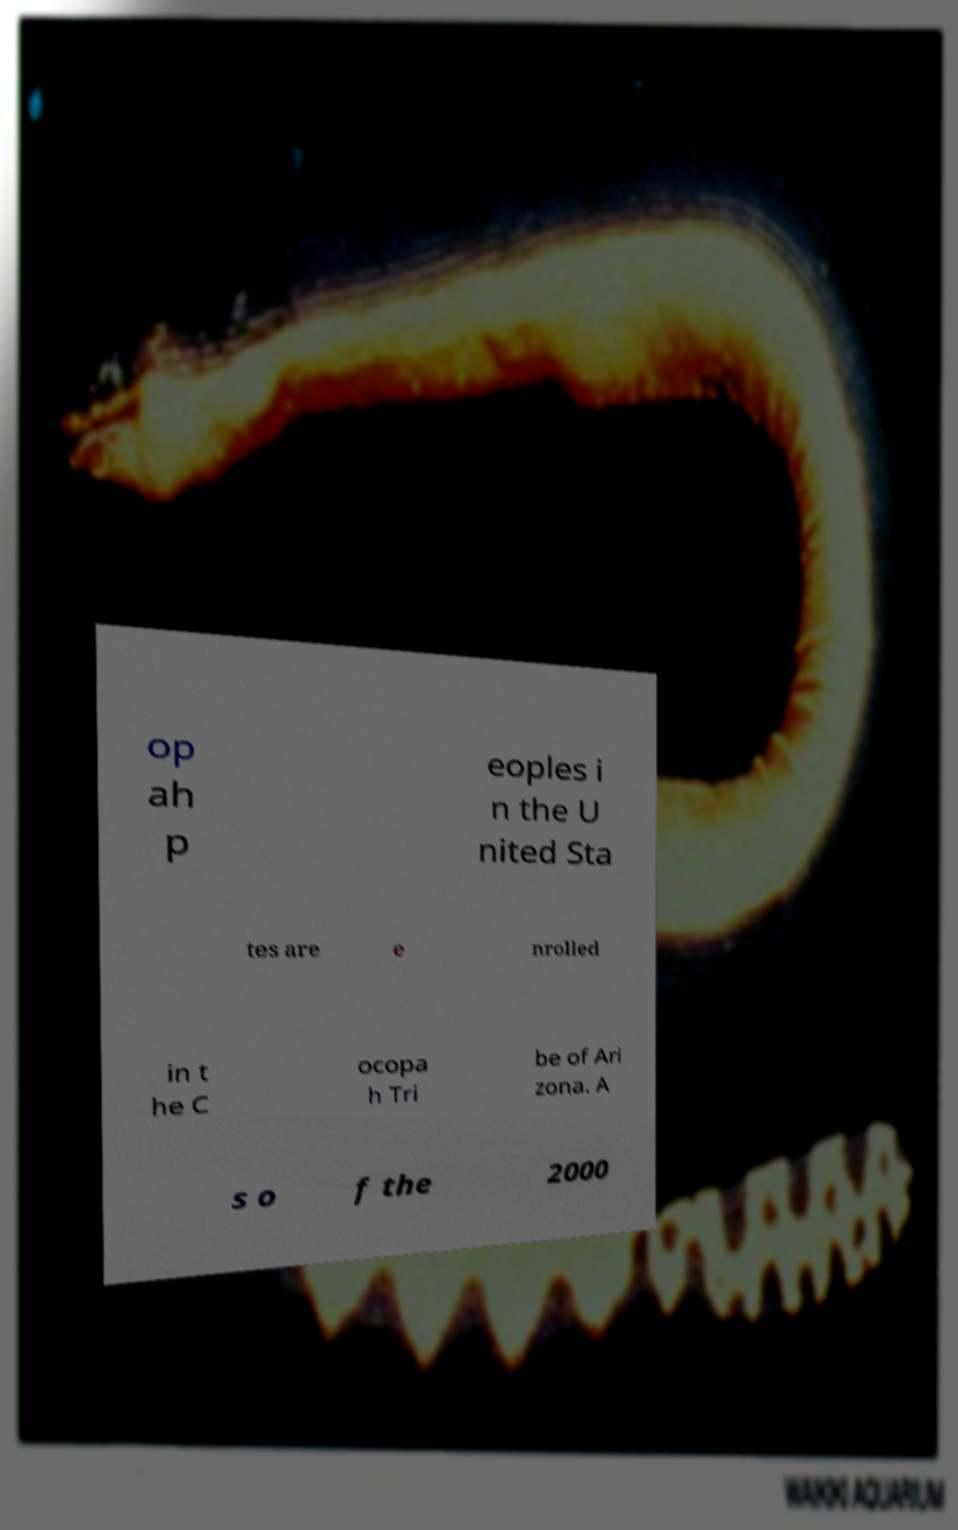For documentation purposes, I need the text within this image transcribed. Could you provide that? op ah p eoples i n the U nited Sta tes are e nrolled in t he C ocopa h Tri be of Ari zona. A s o f the 2000 